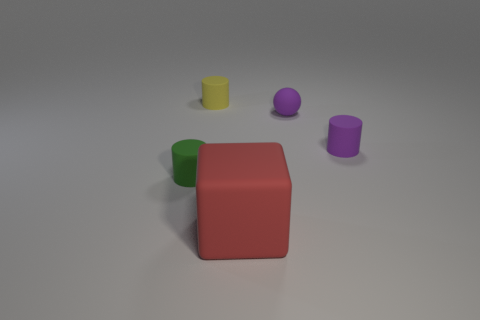Are there any other things that have the same size as the red matte cube?
Give a very brief answer. No. There is a cylinder that is on the right side of the small yellow object; is its color the same as the small sphere?
Your answer should be very brief. Yes. There is a thing that is the same color as the tiny rubber ball; what is it made of?
Keep it short and to the point. Rubber. There is a rubber cylinder that is the same color as the rubber sphere; what is its size?
Your response must be concise. Small. Do the cylinder to the right of the tiny yellow rubber cylinder and the tiny matte ball that is right of the tiny yellow rubber thing have the same color?
Your response must be concise. Yes. Is there a rubber thing that has the same color as the matte ball?
Offer a very short reply. Yes. There is a rubber cylinder that is both in front of the yellow cylinder and to the left of the small rubber sphere; what size is it?
Your answer should be very brief. Small. The tiny rubber thing that is both in front of the rubber ball and to the right of the red block is what color?
Your answer should be very brief. Purple. Are there fewer red matte things behind the small green rubber cylinder than rubber spheres that are behind the red matte object?
Offer a very short reply. Yes. Is there any other thing that has the same color as the large cube?
Keep it short and to the point. No. 